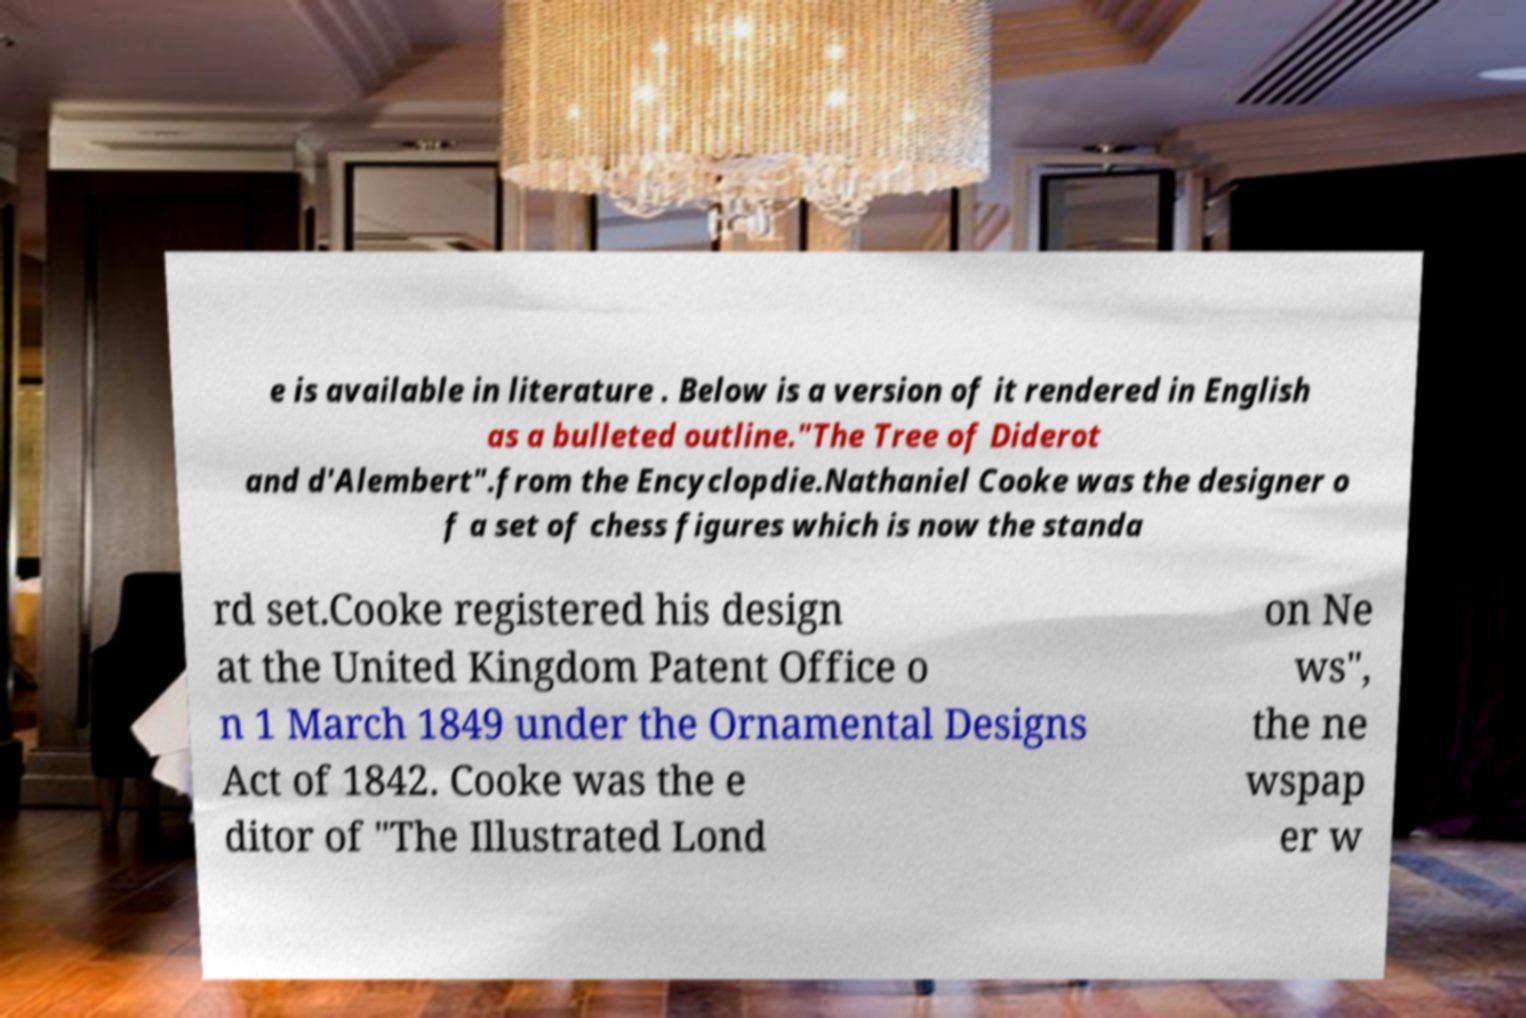There's text embedded in this image that I need extracted. Can you transcribe it verbatim? e is available in literature . Below is a version of it rendered in English as a bulleted outline."The Tree of Diderot and d'Alembert".from the Encyclopdie.Nathaniel Cooke was the designer o f a set of chess figures which is now the standa rd set.Cooke registered his design at the United Kingdom Patent Office o n 1 March 1849 under the Ornamental Designs Act of 1842. Cooke was the e ditor of "The Illustrated Lond on Ne ws", the ne wspap er w 